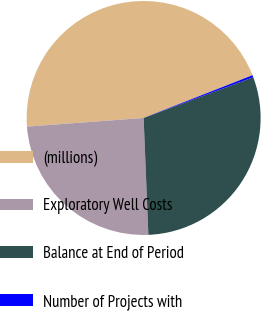Convert chart to OTSL. <chart><loc_0><loc_0><loc_500><loc_500><pie_chart><fcel>(millions)<fcel>Exploratory Well Costs<fcel>Balance at End of Period<fcel>Number of Projects with<nl><fcel>45.22%<fcel>24.47%<fcel>30.02%<fcel>0.29%<nl></chart> 